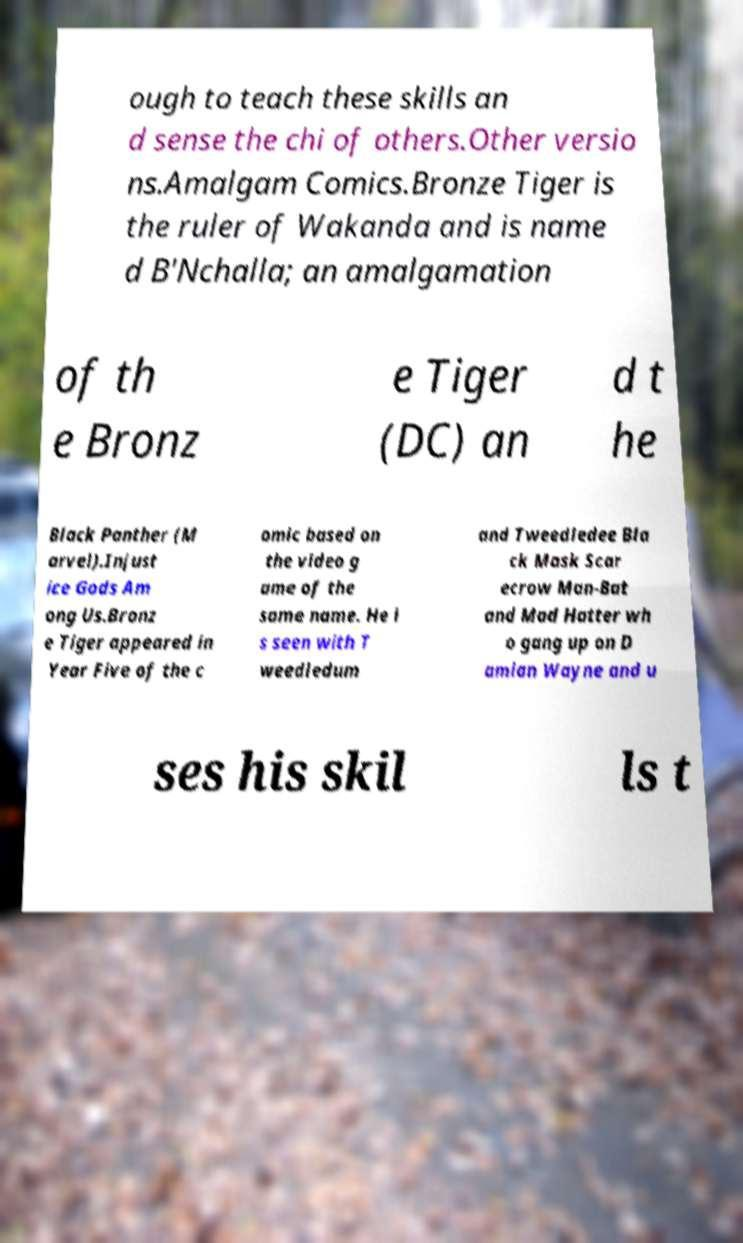Please read and relay the text visible in this image. What does it say? ough to teach these skills an d sense the chi of others.Other versio ns.Amalgam Comics.Bronze Tiger is the ruler of Wakanda and is name d B'Nchalla; an amalgamation of th e Bronz e Tiger (DC) an d t he Black Panther (M arvel).Injust ice Gods Am ong Us.Bronz e Tiger appeared in Year Five of the c omic based on the video g ame of the same name. He i s seen with T weedledum and Tweedledee Bla ck Mask Scar ecrow Man-Bat and Mad Hatter wh o gang up on D amian Wayne and u ses his skil ls t 